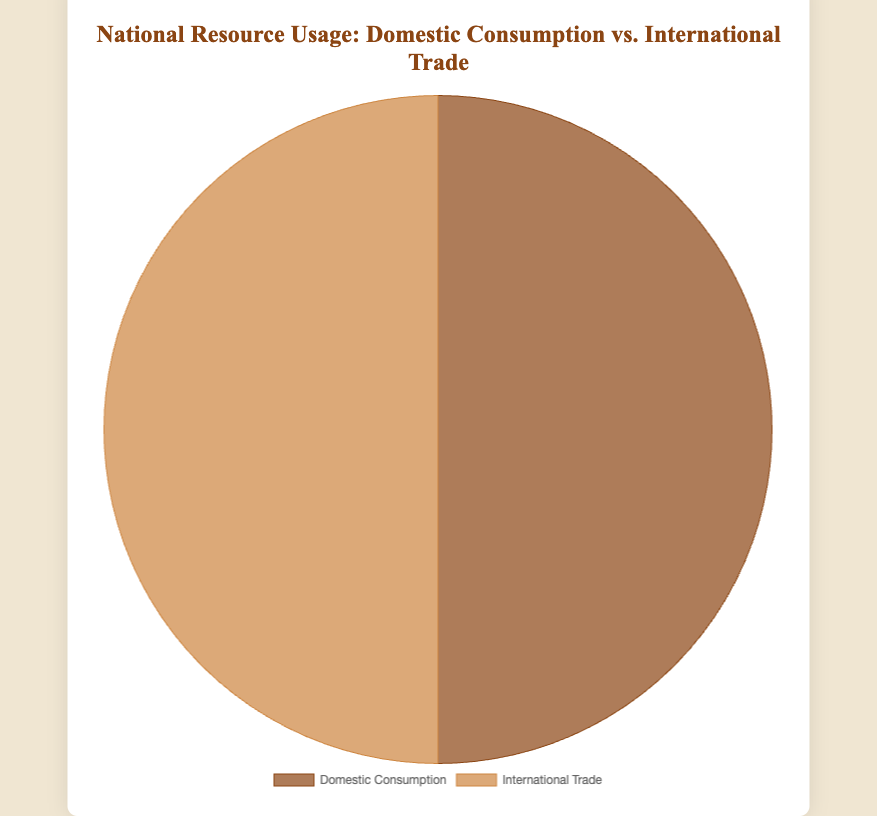What are the two categories compared in the pie chart? The pie chart compares 'Domestic Consumption' with 'International Trade'.
Answer: Domestic Consumption and International Trade Which category has equal representation in the pie chart? Both categories have the same percentage, displaying an equal representation of 50% each.
Answer: Both categories What percentage of the total does Domestic Consumption represent? Since the pie chart has a total of 100%, and Domestic Consumption occupies half of it, the percentage is 50%.
Answer: 50% What is the color used to represent International Trade in the pie chart? The color used is a lighter brown shade.
Answer: Lighter brown Is there a visual legend below the pie chart? Yes, there is a legend positioned at the bottom of the chart.
Answer: Yes If the total resource usage is 200 units, how many units does Domestic Consumption represent? The chart indicates 50% for Domestic Consumption. Calculating 50% of 200: (50/100) * 200 = 100
Answer: 100 units Compare the colors representing the two categories. Domestic Consumption is represented by a darker brown, while International Trade is represented by a lighter brown.
Answer: Darker brown and lighter brown Which category appears first in the legend? The legend positions Domestic Consumption as the first category.
Answer: Domestic Consumption 